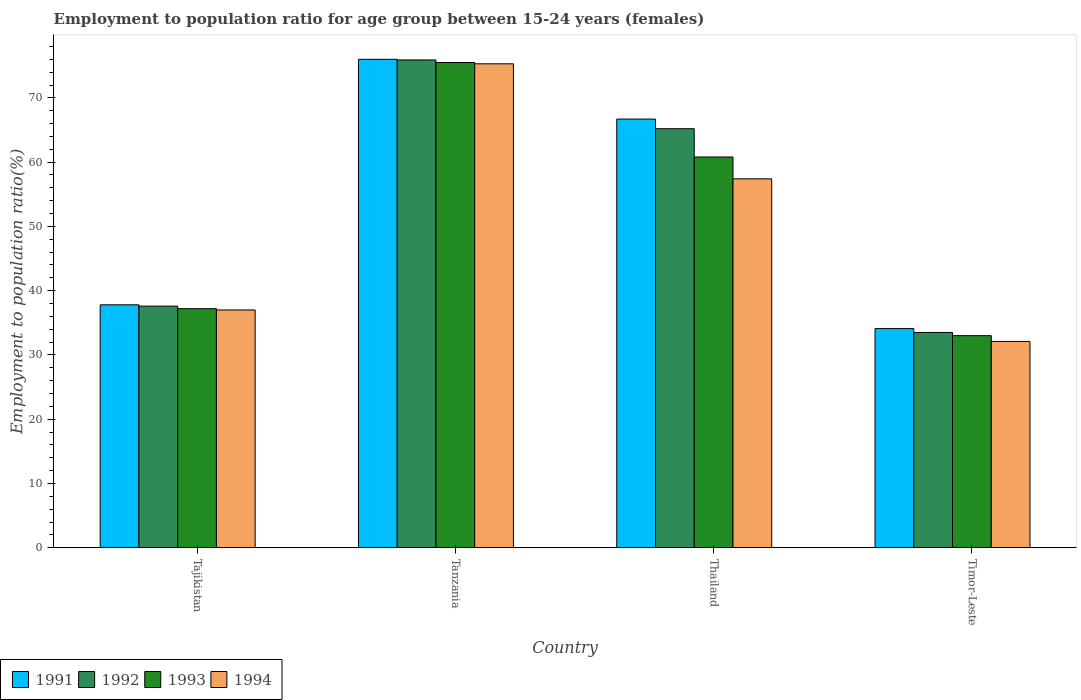How many groups of bars are there?
Offer a very short reply. 4. What is the label of the 2nd group of bars from the left?
Make the answer very short. Tanzania. What is the employment to population ratio in 1991 in Timor-Leste?
Offer a terse response. 34.1. Across all countries, what is the maximum employment to population ratio in 1992?
Ensure brevity in your answer.  75.9. Across all countries, what is the minimum employment to population ratio in 1992?
Your response must be concise. 33.5. In which country was the employment to population ratio in 1993 maximum?
Offer a terse response. Tanzania. In which country was the employment to population ratio in 1991 minimum?
Give a very brief answer. Timor-Leste. What is the total employment to population ratio in 1993 in the graph?
Provide a succinct answer. 206.5. What is the difference between the employment to population ratio in 1994 in Tanzania and that in Thailand?
Keep it short and to the point. 17.9. What is the difference between the employment to population ratio in 1992 in Tajikistan and the employment to population ratio in 1994 in Tanzania?
Provide a short and direct response. -37.7. What is the average employment to population ratio in 1993 per country?
Give a very brief answer. 51.62. What is the difference between the employment to population ratio of/in 1994 and employment to population ratio of/in 1993 in Tanzania?
Your response must be concise. -0.2. What is the ratio of the employment to population ratio in 1994 in Tanzania to that in Thailand?
Your answer should be compact. 1.31. What is the difference between the highest and the second highest employment to population ratio in 1994?
Make the answer very short. -17.9. What is the difference between the highest and the lowest employment to population ratio in 1994?
Keep it short and to the point. 43.2. In how many countries, is the employment to population ratio in 1994 greater than the average employment to population ratio in 1994 taken over all countries?
Your answer should be compact. 2. Is the sum of the employment to population ratio in 1991 in Tajikistan and Thailand greater than the maximum employment to population ratio in 1993 across all countries?
Your response must be concise. Yes. What does the 1st bar from the left in Tajikistan represents?
Provide a succinct answer. 1991. What does the 4th bar from the right in Thailand represents?
Ensure brevity in your answer.  1991. What is the difference between two consecutive major ticks on the Y-axis?
Offer a very short reply. 10. Are the values on the major ticks of Y-axis written in scientific E-notation?
Keep it short and to the point. No. Does the graph contain any zero values?
Your answer should be compact. No. How many legend labels are there?
Your response must be concise. 4. How are the legend labels stacked?
Make the answer very short. Horizontal. What is the title of the graph?
Your answer should be very brief. Employment to population ratio for age group between 15-24 years (females). Does "1973" appear as one of the legend labels in the graph?
Your answer should be very brief. No. What is the label or title of the X-axis?
Offer a terse response. Country. What is the label or title of the Y-axis?
Your answer should be very brief. Employment to population ratio(%). What is the Employment to population ratio(%) of 1991 in Tajikistan?
Your answer should be very brief. 37.8. What is the Employment to population ratio(%) in 1992 in Tajikistan?
Provide a succinct answer. 37.6. What is the Employment to population ratio(%) in 1993 in Tajikistan?
Give a very brief answer. 37.2. What is the Employment to population ratio(%) of 1994 in Tajikistan?
Provide a short and direct response. 37. What is the Employment to population ratio(%) in 1992 in Tanzania?
Your response must be concise. 75.9. What is the Employment to population ratio(%) in 1993 in Tanzania?
Your answer should be compact. 75.5. What is the Employment to population ratio(%) in 1994 in Tanzania?
Your response must be concise. 75.3. What is the Employment to population ratio(%) in 1991 in Thailand?
Ensure brevity in your answer.  66.7. What is the Employment to population ratio(%) in 1992 in Thailand?
Keep it short and to the point. 65.2. What is the Employment to population ratio(%) in 1993 in Thailand?
Your response must be concise. 60.8. What is the Employment to population ratio(%) of 1994 in Thailand?
Your answer should be compact. 57.4. What is the Employment to population ratio(%) of 1991 in Timor-Leste?
Provide a succinct answer. 34.1. What is the Employment to population ratio(%) in 1992 in Timor-Leste?
Your response must be concise. 33.5. What is the Employment to population ratio(%) in 1993 in Timor-Leste?
Your answer should be very brief. 33. What is the Employment to population ratio(%) of 1994 in Timor-Leste?
Your answer should be compact. 32.1. Across all countries, what is the maximum Employment to population ratio(%) in 1992?
Provide a short and direct response. 75.9. Across all countries, what is the maximum Employment to population ratio(%) in 1993?
Provide a short and direct response. 75.5. Across all countries, what is the maximum Employment to population ratio(%) of 1994?
Keep it short and to the point. 75.3. Across all countries, what is the minimum Employment to population ratio(%) in 1991?
Make the answer very short. 34.1. Across all countries, what is the minimum Employment to population ratio(%) of 1992?
Offer a very short reply. 33.5. Across all countries, what is the minimum Employment to population ratio(%) of 1993?
Offer a very short reply. 33. Across all countries, what is the minimum Employment to population ratio(%) of 1994?
Your response must be concise. 32.1. What is the total Employment to population ratio(%) of 1991 in the graph?
Give a very brief answer. 214.6. What is the total Employment to population ratio(%) in 1992 in the graph?
Offer a very short reply. 212.2. What is the total Employment to population ratio(%) of 1993 in the graph?
Provide a short and direct response. 206.5. What is the total Employment to population ratio(%) of 1994 in the graph?
Provide a short and direct response. 201.8. What is the difference between the Employment to population ratio(%) of 1991 in Tajikistan and that in Tanzania?
Provide a succinct answer. -38.2. What is the difference between the Employment to population ratio(%) of 1992 in Tajikistan and that in Tanzania?
Provide a succinct answer. -38.3. What is the difference between the Employment to population ratio(%) of 1993 in Tajikistan and that in Tanzania?
Give a very brief answer. -38.3. What is the difference between the Employment to population ratio(%) in 1994 in Tajikistan and that in Tanzania?
Ensure brevity in your answer.  -38.3. What is the difference between the Employment to population ratio(%) in 1991 in Tajikistan and that in Thailand?
Provide a succinct answer. -28.9. What is the difference between the Employment to population ratio(%) of 1992 in Tajikistan and that in Thailand?
Offer a very short reply. -27.6. What is the difference between the Employment to population ratio(%) of 1993 in Tajikistan and that in Thailand?
Provide a succinct answer. -23.6. What is the difference between the Employment to population ratio(%) of 1994 in Tajikistan and that in Thailand?
Give a very brief answer. -20.4. What is the difference between the Employment to population ratio(%) in 1994 in Tajikistan and that in Timor-Leste?
Ensure brevity in your answer.  4.9. What is the difference between the Employment to population ratio(%) in 1994 in Tanzania and that in Thailand?
Make the answer very short. 17.9. What is the difference between the Employment to population ratio(%) of 1991 in Tanzania and that in Timor-Leste?
Make the answer very short. 41.9. What is the difference between the Employment to population ratio(%) in 1992 in Tanzania and that in Timor-Leste?
Provide a succinct answer. 42.4. What is the difference between the Employment to population ratio(%) in 1993 in Tanzania and that in Timor-Leste?
Offer a terse response. 42.5. What is the difference between the Employment to population ratio(%) in 1994 in Tanzania and that in Timor-Leste?
Your answer should be very brief. 43.2. What is the difference between the Employment to population ratio(%) in 1991 in Thailand and that in Timor-Leste?
Offer a very short reply. 32.6. What is the difference between the Employment to population ratio(%) of 1992 in Thailand and that in Timor-Leste?
Ensure brevity in your answer.  31.7. What is the difference between the Employment to population ratio(%) of 1993 in Thailand and that in Timor-Leste?
Offer a terse response. 27.8. What is the difference between the Employment to population ratio(%) of 1994 in Thailand and that in Timor-Leste?
Provide a short and direct response. 25.3. What is the difference between the Employment to population ratio(%) of 1991 in Tajikistan and the Employment to population ratio(%) of 1992 in Tanzania?
Make the answer very short. -38.1. What is the difference between the Employment to population ratio(%) of 1991 in Tajikistan and the Employment to population ratio(%) of 1993 in Tanzania?
Your response must be concise. -37.7. What is the difference between the Employment to population ratio(%) of 1991 in Tajikistan and the Employment to population ratio(%) of 1994 in Tanzania?
Offer a terse response. -37.5. What is the difference between the Employment to population ratio(%) of 1992 in Tajikistan and the Employment to population ratio(%) of 1993 in Tanzania?
Your answer should be very brief. -37.9. What is the difference between the Employment to population ratio(%) of 1992 in Tajikistan and the Employment to population ratio(%) of 1994 in Tanzania?
Keep it short and to the point. -37.7. What is the difference between the Employment to population ratio(%) in 1993 in Tajikistan and the Employment to population ratio(%) in 1994 in Tanzania?
Your answer should be very brief. -38.1. What is the difference between the Employment to population ratio(%) in 1991 in Tajikistan and the Employment to population ratio(%) in 1992 in Thailand?
Give a very brief answer. -27.4. What is the difference between the Employment to population ratio(%) of 1991 in Tajikistan and the Employment to population ratio(%) of 1994 in Thailand?
Keep it short and to the point. -19.6. What is the difference between the Employment to population ratio(%) in 1992 in Tajikistan and the Employment to population ratio(%) in 1993 in Thailand?
Offer a very short reply. -23.2. What is the difference between the Employment to population ratio(%) of 1992 in Tajikistan and the Employment to population ratio(%) of 1994 in Thailand?
Ensure brevity in your answer.  -19.8. What is the difference between the Employment to population ratio(%) of 1993 in Tajikistan and the Employment to population ratio(%) of 1994 in Thailand?
Your answer should be very brief. -20.2. What is the difference between the Employment to population ratio(%) of 1991 in Tajikistan and the Employment to population ratio(%) of 1993 in Timor-Leste?
Provide a short and direct response. 4.8. What is the difference between the Employment to population ratio(%) of 1991 in Tajikistan and the Employment to population ratio(%) of 1994 in Timor-Leste?
Provide a succinct answer. 5.7. What is the difference between the Employment to population ratio(%) in 1992 in Tajikistan and the Employment to population ratio(%) in 1993 in Timor-Leste?
Ensure brevity in your answer.  4.6. What is the difference between the Employment to population ratio(%) of 1992 in Tajikistan and the Employment to population ratio(%) of 1994 in Timor-Leste?
Give a very brief answer. 5.5. What is the difference between the Employment to population ratio(%) of 1991 in Tanzania and the Employment to population ratio(%) of 1992 in Thailand?
Your answer should be compact. 10.8. What is the difference between the Employment to population ratio(%) of 1991 in Tanzania and the Employment to population ratio(%) of 1994 in Thailand?
Give a very brief answer. 18.6. What is the difference between the Employment to population ratio(%) of 1991 in Tanzania and the Employment to population ratio(%) of 1992 in Timor-Leste?
Offer a terse response. 42.5. What is the difference between the Employment to population ratio(%) of 1991 in Tanzania and the Employment to population ratio(%) of 1994 in Timor-Leste?
Provide a short and direct response. 43.9. What is the difference between the Employment to population ratio(%) of 1992 in Tanzania and the Employment to population ratio(%) of 1993 in Timor-Leste?
Provide a short and direct response. 42.9. What is the difference between the Employment to population ratio(%) of 1992 in Tanzania and the Employment to population ratio(%) of 1994 in Timor-Leste?
Your answer should be compact. 43.8. What is the difference between the Employment to population ratio(%) in 1993 in Tanzania and the Employment to population ratio(%) in 1994 in Timor-Leste?
Your response must be concise. 43.4. What is the difference between the Employment to population ratio(%) of 1991 in Thailand and the Employment to population ratio(%) of 1992 in Timor-Leste?
Offer a terse response. 33.2. What is the difference between the Employment to population ratio(%) of 1991 in Thailand and the Employment to population ratio(%) of 1993 in Timor-Leste?
Your response must be concise. 33.7. What is the difference between the Employment to population ratio(%) of 1991 in Thailand and the Employment to population ratio(%) of 1994 in Timor-Leste?
Offer a terse response. 34.6. What is the difference between the Employment to population ratio(%) in 1992 in Thailand and the Employment to population ratio(%) in 1993 in Timor-Leste?
Give a very brief answer. 32.2. What is the difference between the Employment to population ratio(%) of 1992 in Thailand and the Employment to population ratio(%) of 1994 in Timor-Leste?
Your answer should be very brief. 33.1. What is the difference between the Employment to population ratio(%) in 1993 in Thailand and the Employment to population ratio(%) in 1994 in Timor-Leste?
Your response must be concise. 28.7. What is the average Employment to population ratio(%) of 1991 per country?
Provide a succinct answer. 53.65. What is the average Employment to population ratio(%) in 1992 per country?
Your response must be concise. 53.05. What is the average Employment to population ratio(%) in 1993 per country?
Provide a short and direct response. 51.62. What is the average Employment to population ratio(%) of 1994 per country?
Give a very brief answer. 50.45. What is the difference between the Employment to population ratio(%) in 1992 and Employment to population ratio(%) in 1994 in Tajikistan?
Provide a succinct answer. 0.6. What is the difference between the Employment to population ratio(%) in 1991 and Employment to population ratio(%) in 1994 in Tanzania?
Offer a terse response. 0.7. What is the difference between the Employment to population ratio(%) in 1992 and Employment to population ratio(%) in 1994 in Tanzania?
Ensure brevity in your answer.  0.6. What is the difference between the Employment to population ratio(%) of 1991 and Employment to population ratio(%) of 1992 in Thailand?
Your answer should be compact. 1.5. What is the difference between the Employment to population ratio(%) of 1991 and Employment to population ratio(%) of 1993 in Thailand?
Make the answer very short. 5.9. What is the difference between the Employment to population ratio(%) in 1992 and Employment to population ratio(%) in 1994 in Thailand?
Make the answer very short. 7.8. What is the difference between the Employment to population ratio(%) in 1993 and Employment to population ratio(%) in 1994 in Thailand?
Offer a very short reply. 3.4. What is the difference between the Employment to population ratio(%) of 1991 and Employment to population ratio(%) of 1992 in Timor-Leste?
Ensure brevity in your answer.  0.6. What is the difference between the Employment to population ratio(%) of 1991 and Employment to population ratio(%) of 1993 in Timor-Leste?
Offer a terse response. 1.1. What is the difference between the Employment to population ratio(%) of 1991 and Employment to population ratio(%) of 1994 in Timor-Leste?
Offer a very short reply. 2. What is the difference between the Employment to population ratio(%) in 1993 and Employment to population ratio(%) in 1994 in Timor-Leste?
Offer a terse response. 0.9. What is the ratio of the Employment to population ratio(%) of 1991 in Tajikistan to that in Tanzania?
Provide a succinct answer. 0.5. What is the ratio of the Employment to population ratio(%) of 1992 in Tajikistan to that in Tanzania?
Offer a terse response. 0.5. What is the ratio of the Employment to population ratio(%) of 1993 in Tajikistan to that in Tanzania?
Offer a very short reply. 0.49. What is the ratio of the Employment to population ratio(%) in 1994 in Tajikistan to that in Tanzania?
Your response must be concise. 0.49. What is the ratio of the Employment to population ratio(%) of 1991 in Tajikistan to that in Thailand?
Provide a succinct answer. 0.57. What is the ratio of the Employment to population ratio(%) in 1992 in Tajikistan to that in Thailand?
Give a very brief answer. 0.58. What is the ratio of the Employment to population ratio(%) of 1993 in Tajikistan to that in Thailand?
Ensure brevity in your answer.  0.61. What is the ratio of the Employment to population ratio(%) in 1994 in Tajikistan to that in Thailand?
Offer a very short reply. 0.64. What is the ratio of the Employment to population ratio(%) of 1991 in Tajikistan to that in Timor-Leste?
Your response must be concise. 1.11. What is the ratio of the Employment to population ratio(%) of 1992 in Tajikistan to that in Timor-Leste?
Provide a succinct answer. 1.12. What is the ratio of the Employment to population ratio(%) in 1993 in Tajikistan to that in Timor-Leste?
Ensure brevity in your answer.  1.13. What is the ratio of the Employment to population ratio(%) of 1994 in Tajikistan to that in Timor-Leste?
Offer a very short reply. 1.15. What is the ratio of the Employment to population ratio(%) of 1991 in Tanzania to that in Thailand?
Offer a very short reply. 1.14. What is the ratio of the Employment to population ratio(%) in 1992 in Tanzania to that in Thailand?
Offer a very short reply. 1.16. What is the ratio of the Employment to population ratio(%) in 1993 in Tanzania to that in Thailand?
Offer a very short reply. 1.24. What is the ratio of the Employment to population ratio(%) of 1994 in Tanzania to that in Thailand?
Give a very brief answer. 1.31. What is the ratio of the Employment to population ratio(%) of 1991 in Tanzania to that in Timor-Leste?
Give a very brief answer. 2.23. What is the ratio of the Employment to population ratio(%) of 1992 in Tanzania to that in Timor-Leste?
Offer a terse response. 2.27. What is the ratio of the Employment to population ratio(%) in 1993 in Tanzania to that in Timor-Leste?
Make the answer very short. 2.29. What is the ratio of the Employment to population ratio(%) of 1994 in Tanzania to that in Timor-Leste?
Offer a terse response. 2.35. What is the ratio of the Employment to population ratio(%) in 1991 in Thailand to that in Timor-Leste?
Provide a short and direct response. 1.96. What is the ratio of the Employment to population ratio(%) of 1992 in Thailand to that in Timor-Leste?
Provide a succinct answer. 1.95. What is the ratio of the Employment to population ratio(%) of 1993 in Thailand to that in Timor-Leste?
Your answer should be very brief. 1.84. What is the ratio of the Employment to population ratio(%) in 1994 in Thailand to that in Timor-Leste?
Provide a succinct answer. 1.79. What is the difference between the highest and the second highest Employment to population ratio(%) of 1994?
Your answer should be very brief. 17.9. What is the difference between the highest and the lowest Employment to population ratio(%) in 1991?
Make the answer very short. 41.9. What is the difference between the highest and the lowest Employment to population ratio(%) of 1992?
Your response must be concise. 42.4. What is the difference between the highest and the lowest Employment to population ratio(%) of 1993?
Offer a very short reply. 42.5. What is the difference between the highest and the lowest Employment to population ratio(%) of 1994?
Give a very brief answer. 43.2. 